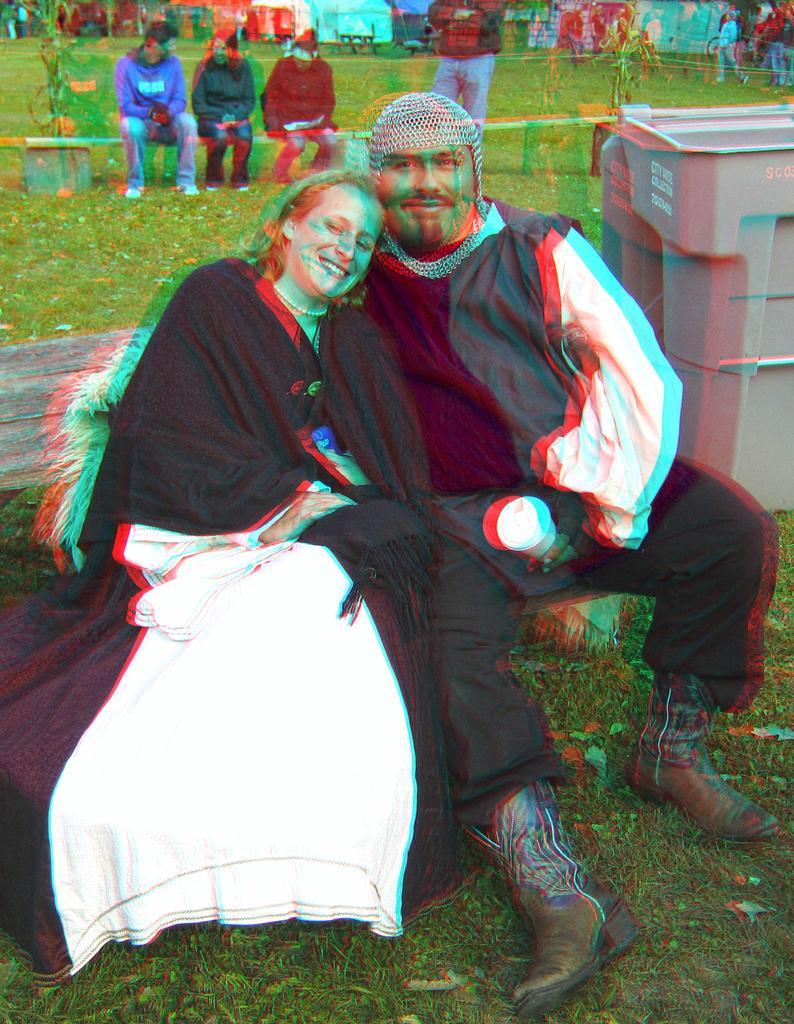Could you give a brief overview of what you see in this image? In this image we can see people sitting and some of them are standing. On the right there is a bin. At the bottom there is grass. The person sitting in the center is holding a glass. There are plants and we can see benches. 